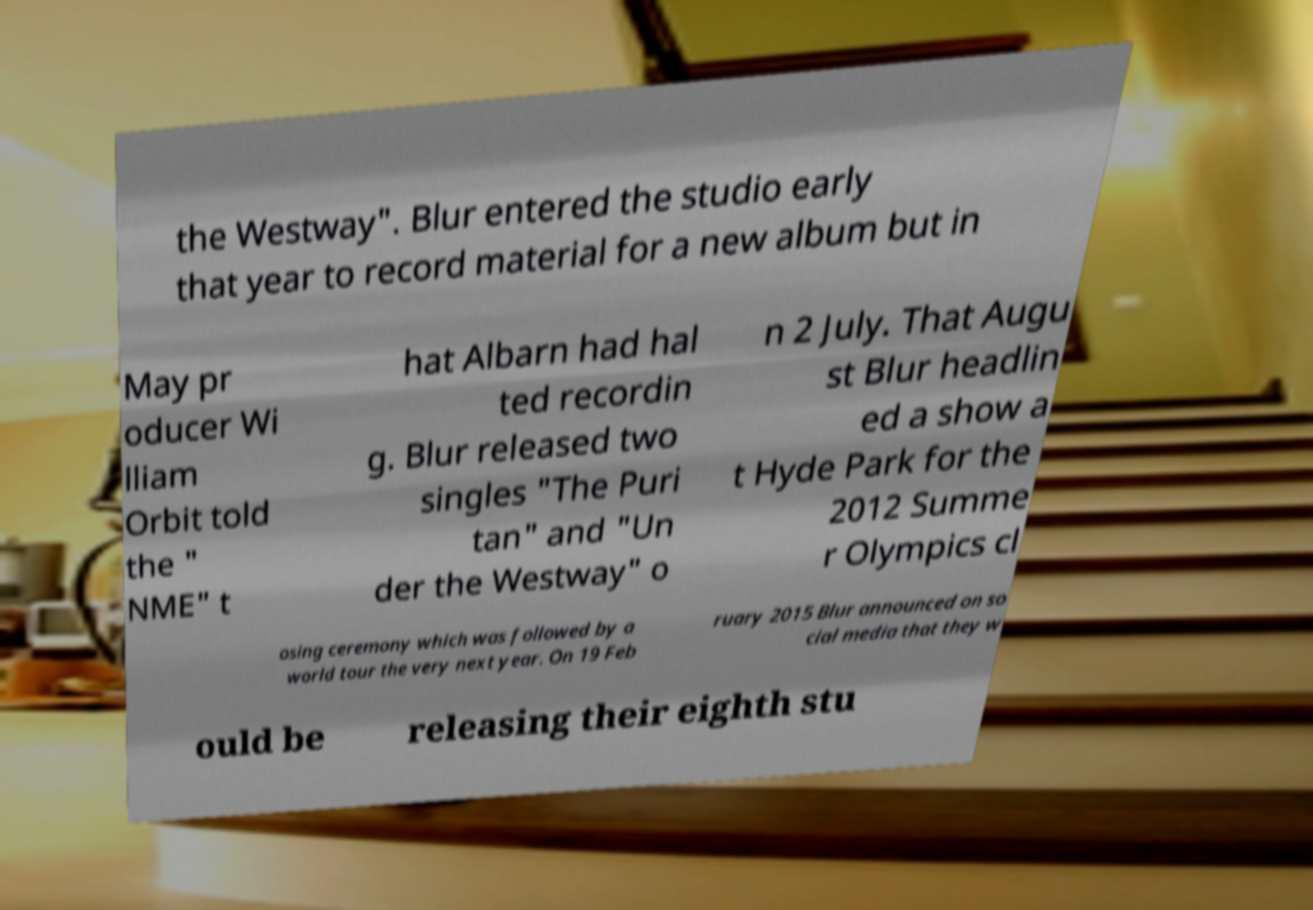Please read and relay the text visible in this image. What does it say? the Westway". Blur entered the studio early that year to record material for a new album but in May pr oducer Wi lliam Orbit told the " NME" t hat Albarn had hal ted recordin g. Blur released two singles "The Puri tan" and "Un der the Westway" o n 2 July. That Augu st Blur headlin ed a show a t Hyde Park for the 2012 Summe r Olympics cl osing ceremony which was followed by a world tour the very next year. On 19 Feb ruary 2015 Blur announced on so cial media that they w ould be releasing their eighth stu 